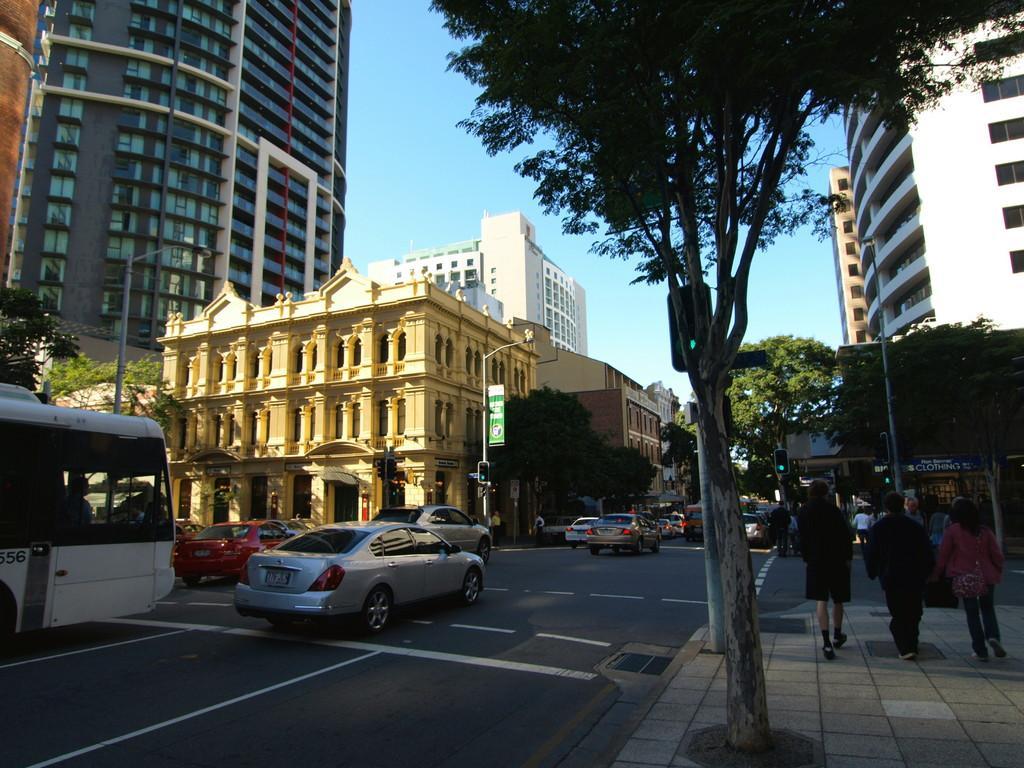Can you describe this image briefly? In this picture we can see many vehicles on the road. On the right side we have trees and vehicles on the foot path & on the left side we have many buildings and trees. 